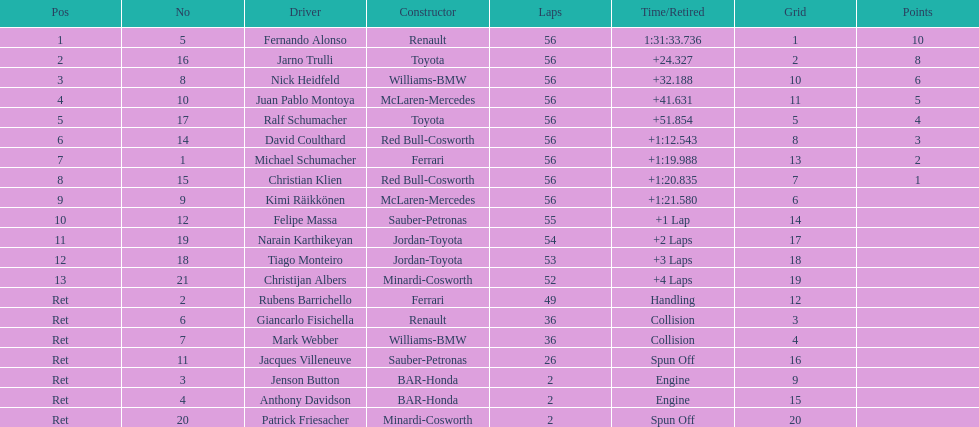How many bmws concluded before webber? 1. 